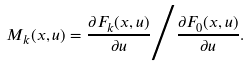Convert formula to latex. <formula><loc_0><loc_0><loc_500><loc_500>M _ { k } ( x , u ) = \frac { \partial F _ { k } ( x , u ) } { \partial u } { \Big / } \frac { \partial F _ { 0 } ( x , u ) } { \partial u } .</formula> 